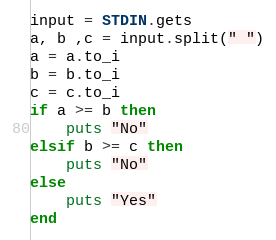Convert code to text. <code><loc_0><loc_0><loc_500><loc_500><_Ruby_>input = STDIN.gets
a, b ,c = input.split(" ")
a = a.to_i
b = b.to_i
c = c.to_i
if a >= b then 
	puts "No"
elsif b >= c then
	puts "No"
else
	puts "Yes"
end
</code> 